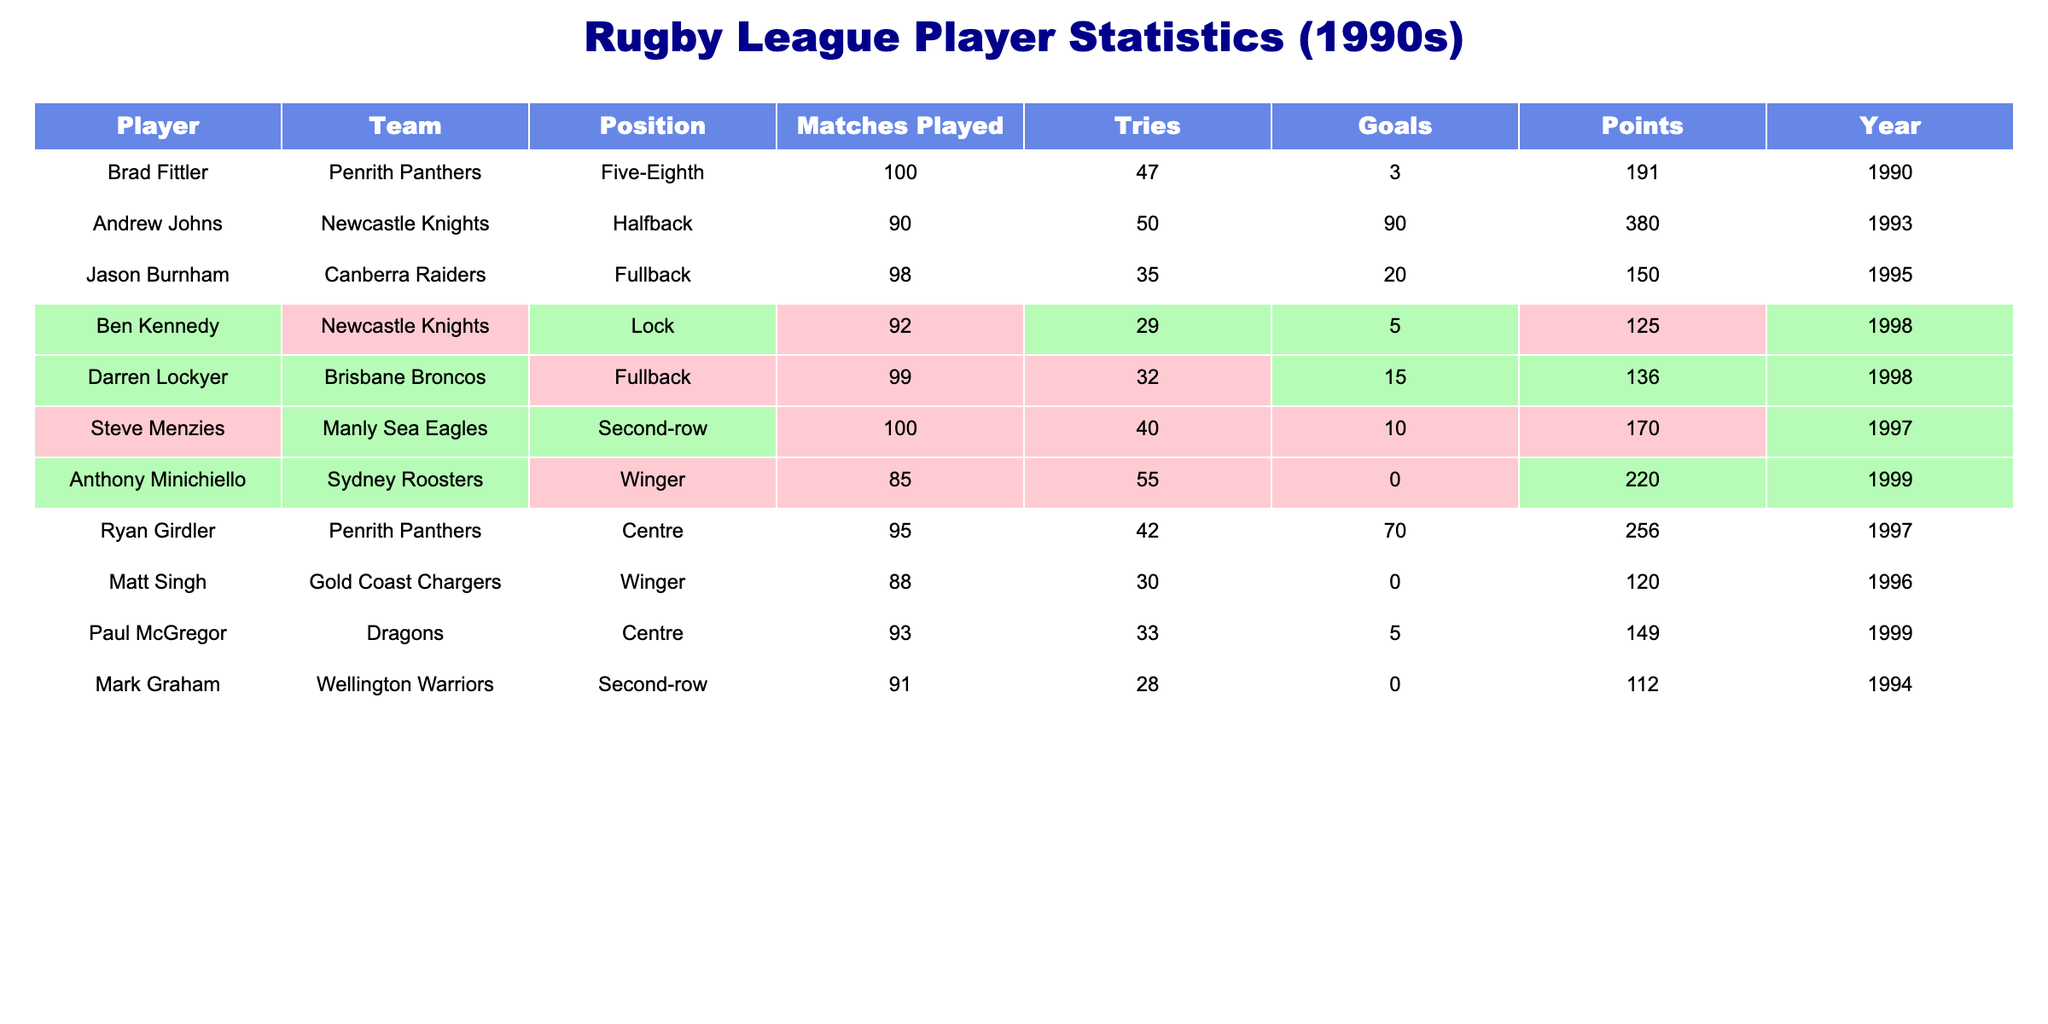What is the total number of tries scored by Andrew Johns? The table shows that Andrew Johns scored 50 tries.
Answer: 50 What was the year in which Jason Burnham played? The table indicates the year Jason Burnham played is 1995.
Answer: 1995 Who scored the highest number of points among the players? By reviewing the points column, Andrew Johns scored 380 points, which is the highest in the table.
Answer: Andrew Johns Which player had both tries and goals above average? By calculating the average for tries (36.8) and goals (14.5), Ryan Girdler (42 tries, 70 goals) is the only player above average in both categories.
Answer: Ryan Girdler How many matches did Darren Lockyer play? The table lists that Darren Lockyer played 99 matches.
Answer: 99 Is it true that Matt Singh scored more points than Paul McGregor? Comparing their points, Matt Singh scored 120 points and Paul McGregor scored 149 points, so the statement is false.
Answer: No What is the average number of goals scored by players in the table? Summing the total goals (3 + 90 + 20 + 5 + 15 + 10 + 0 + 70 + 0 + 5 = 218) and dividing by the number of players (10), we have an average of 21.8 goals scored.
Answer: 21.8 Which position had the highest total number of tries? Adding the tries scored for each position shows that the overall highest is Winger, with 85 tries (55 + 30).
Answer: Winger What is the difference in points between the player with the most points and the player with the least points? Andrew Johns has the most points (380), and Mark Graham has the least (112). The difference is 380 - 112 = 268 points.
Answer: 268 Which team had the most players listed in the table? By counting, Newcastle Knights has 3 players listed (Andrew Johns, Ben Kennedy) which is the highest.
Answer: Newcastle Knights 